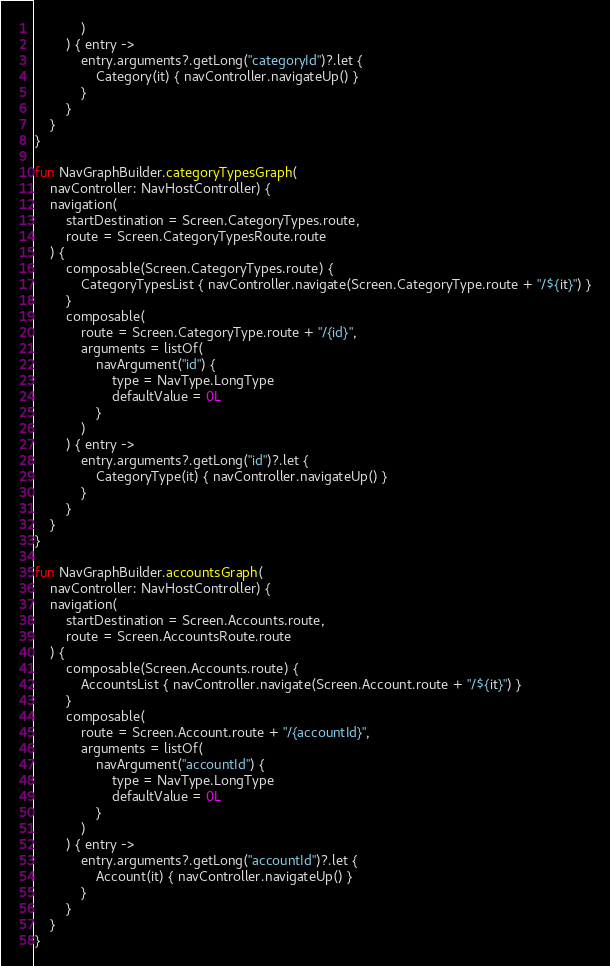Convert code to text. <code><loc_0><loc_0><loc_500><loc_500><_Kotlin_>            )
        ) { entry ->
            entry.arguments?.getLong("categoryId")?.let {
                Category(it) { navController.navigateUp() }
            }
        }
    }
}

fun NavGraphBuilder.categoryTypesGraph(
    navController: NavHostController) {
    navigation(
        startDestination = Screen.CategoryTypes.route,
        route = Screen.CategoryTypesRoute.route
    ) {
        composable(Screen.CategoryTypes.route) {
            CategoryTypesList { navController.navigate(Screen.CategoryType.route + "/${it}") }
        }
        composable(
            route = Screen.CategoryType.route + "/{id}",
            arguments = listOf(
                navArgument("id") {
                    type = NavType.LongType
                    defaultValue = 0L
                }
            )
        ) { entry ->
            entry.arguments?.getLong("id")?.let {
                CategoryType(it) { navController.navigateUp() }
            }
        }
    }
}

fun NavGraphBuilder.accountsGraph(
    navController: NavHostController) {
    navigation(
        startDestination = Screen.Accounts.route,
        route = Screen.AccountsRoute.route
    ) {
        composable(Screen.Accounts.route) {
            AccountsList { navController.navigate(Screen.Account.route + "/${it}") }
        }
        composable(
            route = Screen.Account.route + "/{accountId}",
            arguments = listOf(
                navArgument("accountId") {
                    type = NavType.LongType
                    defaultValue = 0L
                }
            )
        ) { entry ->
            entry.arguments?.getLong("accountId")?.let {
                Account(it) { navController.navigateUp() }
            }
        }
    }
}</code> 